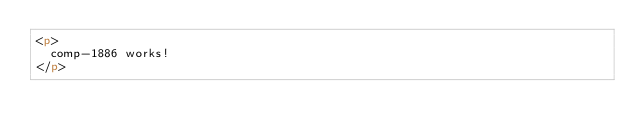Convert code to text. <code><loc_0><loc_0><loc_500><loc_500><_HTML_><p>
  comp-1886 works!
</p>
</code> 